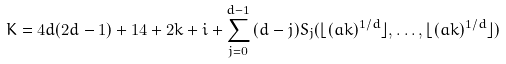Convert formula to latex. <formula><loc_0><loc_0><loc_500><loc_500>K = 4 d ( 2 d - 1 ) + 1 4 + 2 k + i + \sum _ { j = 0 } ^ { d - 1 } { ( d - j ) S _ { j } ( \lfloor ( a k ) ^ { 1 / d } \rfloor , \dots , \lfloor ( a k ) ^ { 1 / d } \rfloor ) }</formula> 